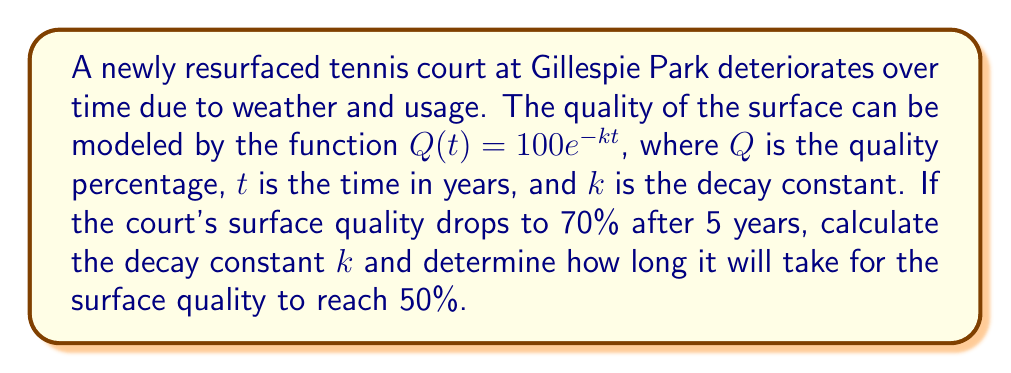Solve this math problem. 1) We start with the given function: $Q(t) = 100e^{-kt}$

2) We know that after 5 years, the quality is 70%. Let's substitute these values:
   $70 = 100e^{-k(5)}$

3) Divide both sides by 100:
   $0.7 = e^{-5k}$

4) Take the natural logarithm of both sides:
   $\ln(0.7) = -5k$

5) Solve for $k$:
   $k = -\frac{\ln(0.7)}{5} \approx 0.0713$

6) Now that we have $k$, we can find when the quality reaches 50%:
   $50 = 100e^{-0.0713t}$

7) Divide both sides by 100:
   $0.5 = e^{-0.0713t}$

8) Take the natural logarithm of both sides:
   $\ln(0.5) = -0.0713t$

9) Solve for $t$:
   $t = -\frac{\ln(0.5)}{0.0713} \approx 9.72$ years
Answer: $k \approx 0.0713$; $t \approx 9.72$ years 